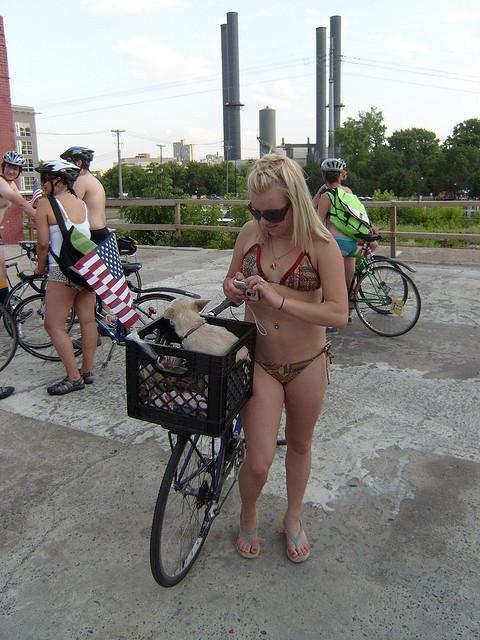How many bicycles can be seen?
Give a very brief answer. 3. How many people are there?
Give a very brief answer. 3. How many motorcycles can be seen?
Give a very brief answer. 0. 